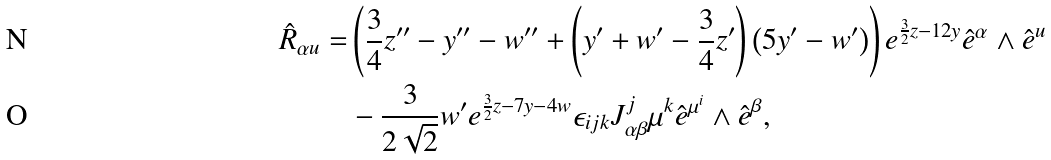<formula> <loc_0><loc_0><loc_500><loc_500>\hat { R } _ { \alpha u } = & \left ( \frac { 3 } { 4 } z ^ { \prime \prime } - y ^ { \prime \prime } - w ^ { \prime \prime } + \left ( y ^ { \prime } + w ^ { \prime } - \frac { 3 } { 4 } z ^ { \prime } \right ) \left ( 5 y ^ { \prime } - w ^ { \prime } \right ) \right ) e ^ { \frac { 3 } { 2 } z - 1 2 y } \hat { e } ^ { \alpha } \wedge \hat { e } ^ { u } \\ & - \frac { 3 } { 2 \sqrt { 2 } } w ^ { \prime } e ^ { \frac { 3 } { 2 } z - 7 y - 4 w } \epsilon _ { i j k } J ^ { j } _ { \alpha \beta } \mu ^ { k } \hat { e } ^ { \mu ^ { i } } \wedge \hat { e } ^ { \beta } ,</formula> 